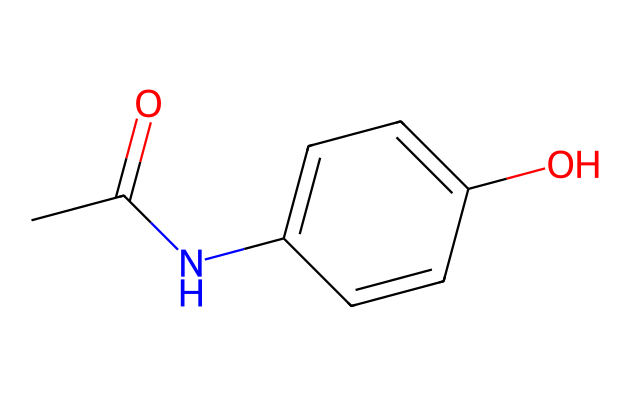What is the common name for the compound represented by this SMILES? The SMILES indicates the presence of an acetyl group (CC(=O)) and an amine (-N-) adjacent to a phenolic compound (c1ccc(O)cc1). This structure corresponds to acetaminophen, commonly known as paracetamol.
Answer: acetaminophen How many carbon atoms are present in this chemical structure? By examining the SMILES, we identify connected carbon atoms: two from the acetyl group and four from the benzene ring (the "c" symbols represent aromatic carbon atoms). Adding these gives a total of eight carbon atoms.
Answer: eight What functional groups are present in acetaminophen? The structure shows an acetyl group (CC(=O)) and a hydroxyl group (O - from the "-OH" on the benzene ring). An amine group (-NH) is also present. Therefore, the functional groups are acetyl, hydroxyl, and amine.
Answer: acetyl, hydroxyl, amine What is the total number of hydrogen atoms in this molecule? The molecule's hydrogen count can be derived from the valence requirements of carbons and other atoms. The benzene ring has five hydrogen and each functional group contributes hydrogen accordingly. Counting reveals a total of nine hydrogen atoms after considering all valences.
Answer: nine Is acetaminophen a polar or non-polar substance? The presence of the hydroxyl (-OH) and amine (-NH) groups indicates hydrogen bonding potential, which contributes to polarity in the structure. Acetaminophen is therefore classified as a polar non-electrolyte due to its solubility characteristics in water.
Answer: polar What is the molecular formula of acetaminophen? Counting the atoms from the representation, we arrive at C8 (carbons), H9 (hydrogens), N1 (nitrogen), and O2 (oxygens), leading to the formula C8H9NO2.
Answer: C8H9NO2 